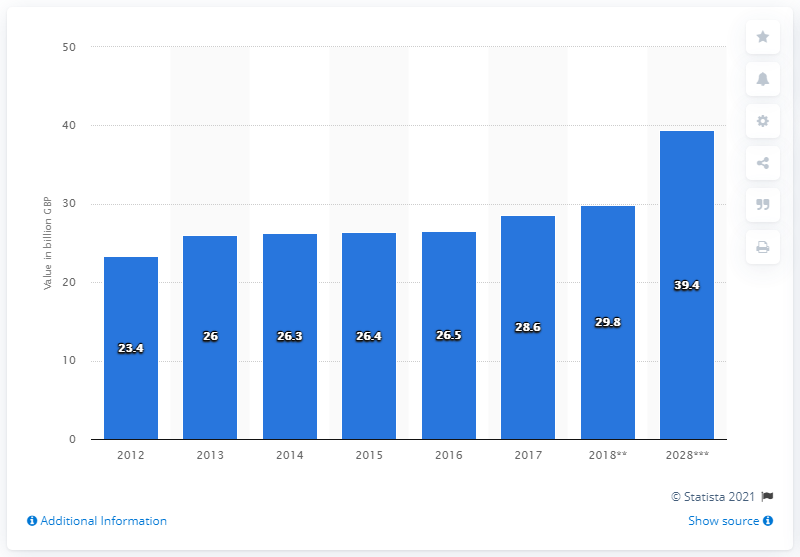Draw attention to some important aspects in this diagram. The sum of the first and last bars in the chart is 62.8. The average annual spending of international tourists in the United Kingdom (UK) from 2012 to 2028 ranged from 39.4 billion British pounds, with the highest recorded value in 2021. In 2017, the value of visitor exports was 28.6 million. 